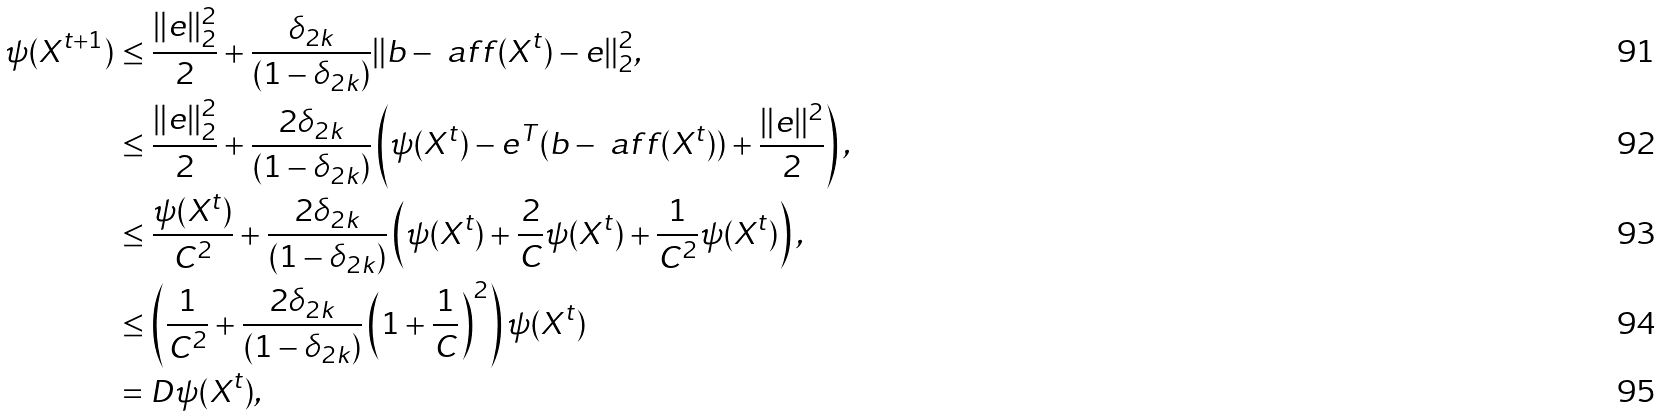<formula> <loc_0><loc_0><loc_500><loc_500>\psi ( X ^ { t + 1 } ) & \leq \frac { \| e \| _ { 2 } ^ { 2 } } { 2 } + \frac { \delta _ { 2 k } } { ( 1 - \delta _ { 2 k } ) } \| b - \ a f f ( X ^ { t } ) - e \| _ { 2 } ^ { 2 } , \\ & \leq \frac { \| e \| _ { 2 } ^ { 2 } } { 2 } + \frac { 2 \delta _ { 2 k } } { ( 1 - \delta _ { 2 k } ) } \left ( \psi ( X ^ { t } ) - e ^ { T } ( b - \ a f f ( X ^ { t } ) ) + \frac { \| e \| ^ { 2 } } { 2 } \right ) , \\ & \leq \frac { \psi ( X ^ { t } ) } { C ^ { 2 } } + \frac { 2 \delta _ { 2 k } } { ( 1 - \delta _ { 2 k } ) } \left ( \psi ( X ^ { t } ) + \frac { 2 } { C } \psi ( X ^ { t } ) + \frac { 1 } { C ^ { 2 } } \psi ( X ^ { t } ) \right ) , \\ & \leq \left ( \frac { 1 } { C ^ { 2 } } + \frac { 2 \delta _ { 2 k } } { ( 1 - \delta _ { 2 k } ) } \left ( 1 + \frac { 1 } { C } \right ) ^ { 2 } \right ) \psi ( X ^ { t } ) \\ & = D \psi ( X ^ { t } ) ,</formula> 